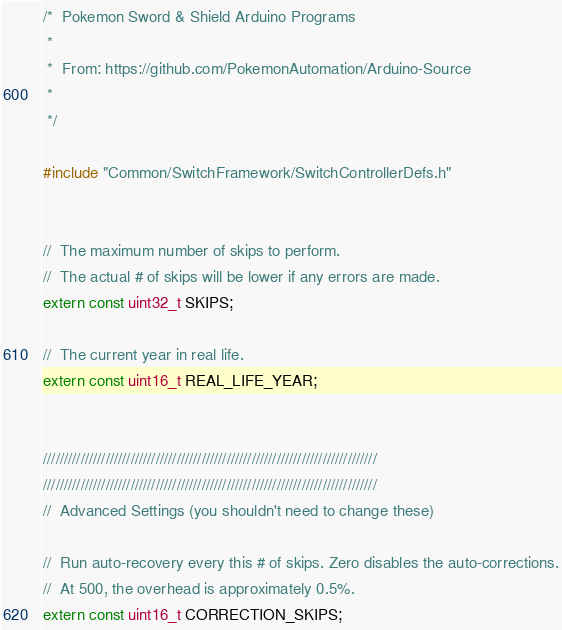<code> <loc_0><loc_0><loc_500><loc_500><_C_>/*  Pokemon Sword & Shield Arduino Programs
 * 
 *  From: https://github.com/PokemonAutomation/Arduino-Source
 * 
 */

#include "Common/SwitchFramework/SwitchControllerDefs.h"


//  The maximum number of skips to perform.
//  The actual # of skips will be lower if any errors are made.
extern const uint32_t SKIPS;

//  The current year in real life.
extern const uint16_t REAL_LIFE_YEAR;


////////////////////////////////////////////////////////////////////////////////
////////////////////////////////////////////////////////////////////////////////
//  Advanced Settings (you shouldn't need to change these)

//  Run auto-recovery every this # of skips. Zero disables the auto-corrections.
//  At 500, the overhead is approximately 0.5%.
extern const uint16_t CORRECTION_SKIPS;


</code> 